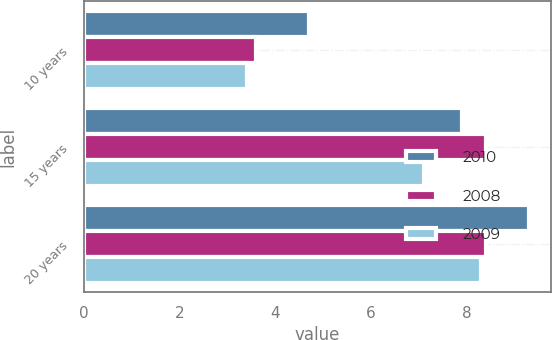Convert chart. <chart><loc_0><loc_0><loc_500><loc_500><stacked_bar_chart><ecel><fcel>10 years<fcel>15 years<fcel>20 years<nl><fcel>2010<fcel>4.7<fcel>7.9<fcel>9.3<nl><fcel>2008<fcel>3.6<fcel>8.4<fcel>8.4<nl><fcel>2009<fcel>3.4<fcel>7.1<fcel>8.3<nl></chart> 